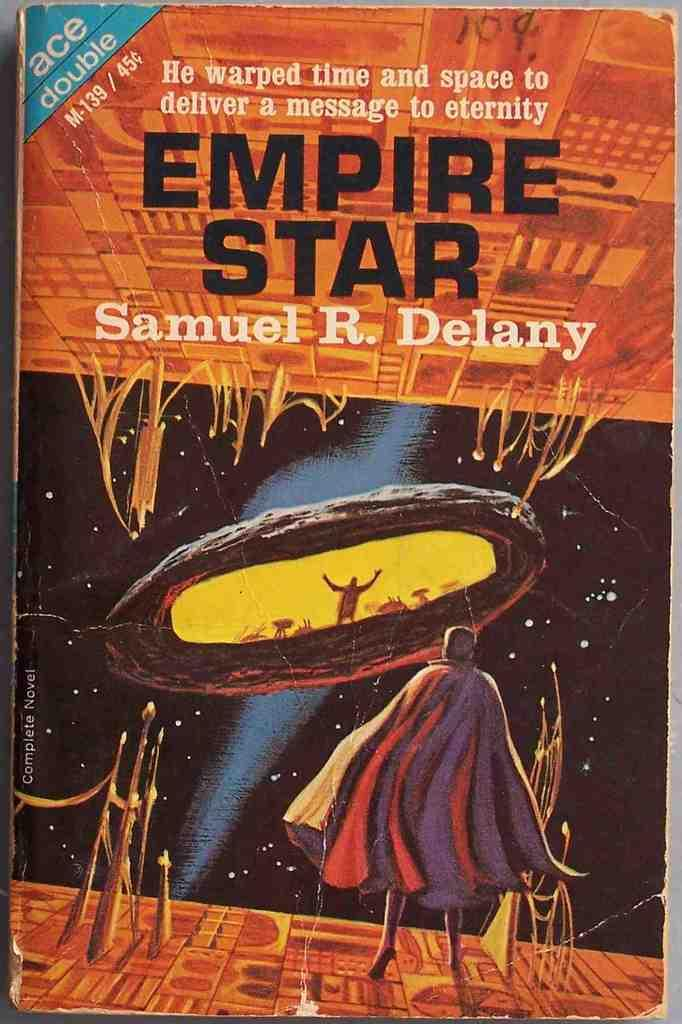<image>
Share a concise interpretation of the image provided. A cover of the book titled Empire Star. 